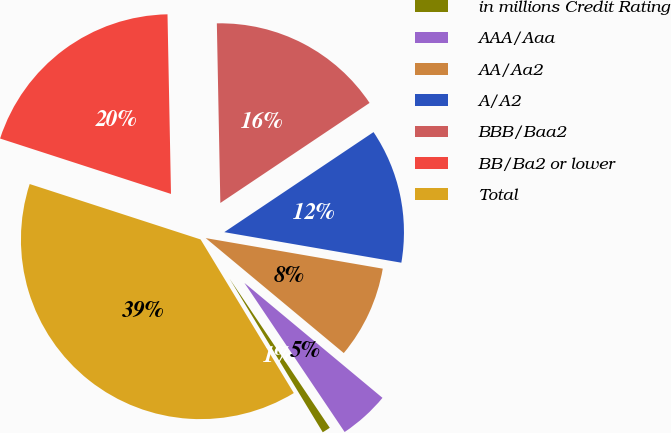Convert chart. <chart><loc_0><loc_0><loc_500><loc_500><pie_chart><fcel>in millions Credit Rating<fcel>AAA/Aaa<fcel>AA/Aa2<fcel>A/A2<fcel>BBB/Baa2<fcel>BB/Ba2 or lower<fcel>Total<nl><fcel>0.74%<fcel>4.53%<fcel>8.33%<fcel>12.12%<fcel>15.91%<fcel>19.7%<fcel>38.67%<nl></chart> 